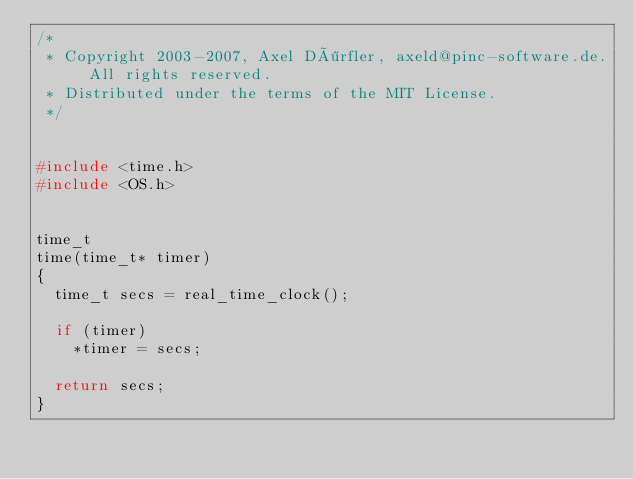<code> <loc_0><loc_0><loc_500><loc_500><_C_>/* 
 * Copyright 2003-2007, Axel Dörfler, axeld@pinc-software.de. All rights reserved.
 * Distributed under the terms of the MIT License.
 */


#include <time.h>
#include <OS.h>


time_t
time(time_t* timer)
{
	time_t secs = real_time_clock();

	if (timer)
		*timer = secs;

	return secs;
}
</code> 